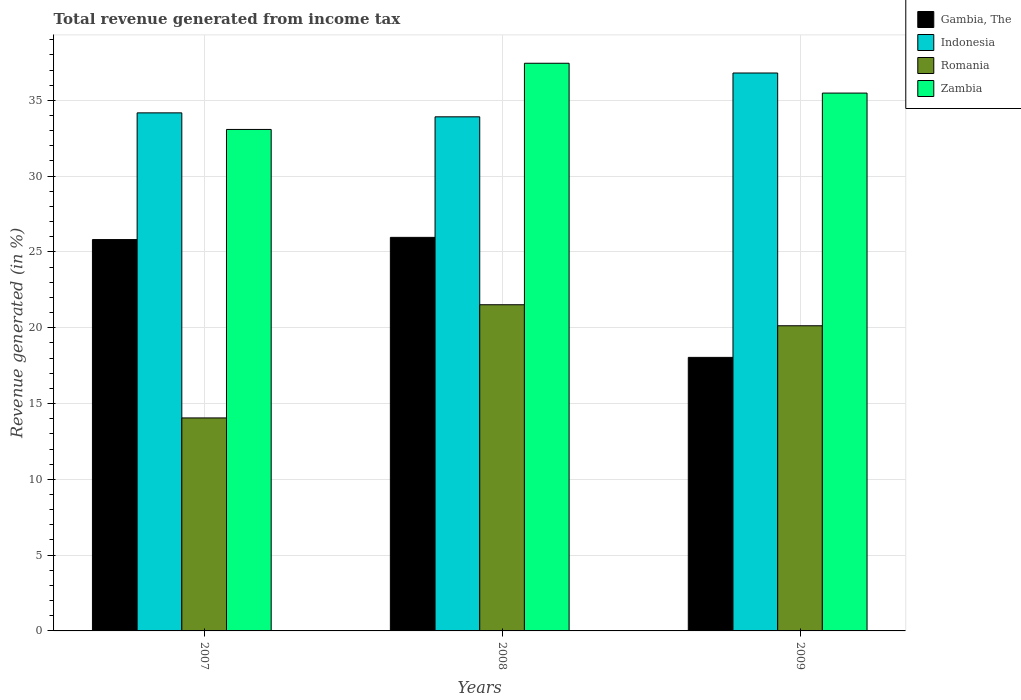How many different coloured bars are there?
Give a very brief answer. 4. Are the number of bars per tick equal to the number of legend labels?
Offer a terse response. Yes. Are the number of bars on each tick of the X-axis equal?
Keep it short and to the point. Yes. How many bars are there on the 2nd tick from the right?
Keep it short and to the point. 4. In how many cases, is the number of bars for a given year not equal to the number of legend labels?
Ensure brevity in your answer.  0. What is the total revenue generated in Gambia, The in 2009?
Make the answer very short. 18.04. Across all years, what is the maximum total revenue generated in Indonesia?
Your response must be concise. 36.8. Across all years, what is the minimum total revenue generated in Zambia?
Ensure brevity in your answer.  33.08. What is the total total revenue generated in Indonesia in the graph?
Make the answer very short. 104.89. What is the difference between the total revenue generated in Zambia in 2007 and that in 2009?
Your answer should be very brief. -2.4. What is the difference between the total revenue generated in Zambia in 2007 and the total revenue generated in Gambia, The in 2009?
Provide a succinct answer. 15.04. What is the average total revenue generated in Romania per year?
Keep it short and to the point. 18.57. In the year 2007, what is the difference between the total revenue generated in Zambia and total revenue generated in Gambia, The?
Provide a short and direct response. 7.26. What is the ratio of the total revenue generated in Indonesia in 2007 to that in 2009?
Make the answer very short. 0.93. What is the difference between the highest and the second highest total revenue generated in Romania?
Make the answer very short. 1.39. What is the difference between the highest and the lowest total revenue generated in Indonesia?
Keep it short and to the point. 2.89. In how many years, is the total revenue generated in Romania greater than the average total revenue generated in Romania taken over all years?
Your answer should be very brief. 2. Is the sum of the total revenue generated in Romania in 2008 and 2009 greater than the maximum total revenue generated in Zambia across all years?
Your answer should be compact. Yes. What does the 3rd bar from the left in 2009 represents?
Keep it short and to the point. Romania. What does the 4th bar from the right in 2008 represents?
Offer a very short reply. Gambia, The. How many bars are there?
Offer a terse response. 12. Are all the bars in the graph horizontal?
Ensure brevity in your answer.  No. What is the difference between two consecutive major ticks on the Y-axis?
Offer a very short reply. 5. Where does the legend appear in the graph?
Offer a very short reply. Top right. How are the legend labels stacked?
Provide a short and direct response. Vertical. What is the title of the graph?
Provide a short and direct response. Total revenue generated from income tax. What is the label or title of the Y-axis?
Give a very brief answer. Revenue generated (in %). What is the Revenue generated (in %) of Gambia, The in 2007?
Ensure brevity in your answer.  25.82. What is the Revenue generated (in %) of Indonesia in 2007?
Offer a very short reply. 34.17. What is the Revenue generated (in %) in Romania in 2007?
Your response must be concise. 14.05. What is the Revenue generated (in %) of Zambia in 2007?
Offer a terse response. 33.08. What is the Revenue generated (in %) in Gambia, The in 2008?
Offer a terse response. 25.96. What is the Revenue generated (in %) of Indonesia in 2008?
Provide a short and direct response. 33.91. What is the Revenue generated (in %) in Romania in 2008?
Give a very brief answer. 21.52. What is the Revenue generated (in %) of Zambia in 2008?
Your response must be concise. 37.45. What is the Revenue generated (in %) in Gambia, The in 2009?
Make the answer very short. 18.04. What is the Revenue generated (in %) in Indonesia in 2009?
Provide a short and direct response. 36.8. What is the Revenue generated (in %) of Romania in 2009?
Make the answer very short. 20.13. What is the Revenue generated (in %) of Zambia in 2009?
Offer a terse response. 35.48. Across all years, what is the maximum Revenue generated (in %) of Gambia, The?
Your answer should be compact. 25.96. Across all years, what is the maximum Revenue generated (in %) in Indonesia?
Ensure brevity in your answer.  36.8. Across all years, what is the maximum Revenue generated (in %) in Romania?
Your response must be concise. 21.52. Across all years, what is the maximum Revenue generated (in %) of Zambia?
Keep it short and to the point. 37.45. Across all years, what is the minimum Revenue generated (in %) of Gambia, The?
Make the answer very short. 18.04. Across all years, what is the minimum Revenue generated (in %) of Indonesia?
Keep it short and to the point. 33.91. Across all years, what is the minimum Revenue generated (in %) in Romania?
Your response must be concise. 14.05. Across all years, what is the minimum Revenue generated (in %) in Zambia?
Your answer should be compact. 33.08. What is the total Revenue generated (in %) of Gambia, The in the graph?
Your answer should be very brief. 69.82. What is the total Revenue generated (in %) in Indonesia in the graph?
Give a very brief answer. 104.89. What is the total Revenue generated (in %) in Romania in the graph?
Your response must be concise. 55.7. What is the total Revenue generated (in %) of Zambia in the graph?
Give a very brief answer. 106.01. What is the difference between the Revenue generated (in %) in Gambia, The in 2007 and that in 2008?
Make the answer very short. -0.15. What is the difference between the Revenue generated (in %) of Indonesia in 2007 and that in 2008?
Your answer should be very brief. 0.26. What is the difference between the Revenue generated (in %) of Romania in 2007 and that in 2008?
Provide a short and direct response. -7.47. What is the difference between the Revenue generated (in %) of Zambia in 2007 and that in 2008?
Give a very brief answer. -4.37. What is the difference between the Revenue generated (in %) of Gambia, The in 2007 and that in 2009?
Your answer should be compact. 7.77. What is the difference between the Revenue generated (in %) of Indonesia in 2007 and that in 2009?
Provide a succinct answer. -2.63. What is the difference between the Revenue generated (in %) in Romania in 2007 and that in 2009?
Give a very brief answer. -6.08. What is the difference between the Revenue generated (in %) in Zambia in 2007 and that in 2009?
Make the answer very short. -2.4. What is the difference between the Revenue generated (in %) in Gambia, The in 2008 and that in 2009?
Offer a very short reply. 7.92. What is the difference between the Revenue generated (in %) of Indonesia in 2008 and that in 2009?
Provide a succinct answer. -2.89. What is the difference between the Revenue generated (in %) of Romania in 2008 and that in 2009?
Offer a very short reply. 1.39. What is the difference between the Revenue generated (in %) of Zambia in 2008 and that in 2009?
Provide a short and direct response. 1.97. What is the difference between the Revenue generated (in %) of Gambia, The in 2007 and the Revenue generated (in %) of Indonesia in 2008?
Provide a succinct answer. -8.1. What is the difference between the Revenue generated (in %) of Gambia, The in 2007 and the Revenue generated (in %) of Romania in 2008?
Ensure brevity in your answer.  4.3. What is the difference between the Revenue generated (in %) in Gambia, The in 2007 and the Revenue generated (in %) in Zambia in 2008?
Give a very brief answer. -11.63. What is the difference between the Revenue generated (in %) in Indonesia in 2007 and the Revenue generated (in %) in Romania in 2008?
Your response must be concise. 12.66. What is the difference between the Revenue generated (in %) in Indonesia in 2007 and the Revenue generated (in %) in Zambia in 2008?
Your answer should be very brief. -3.27. What is the difference between the Revenue generated (in %) of Romania in 2007 and the Revenue generated (in %) of Zambia in 2008?
Your answer should be compact. -23.4. What is the difference between the Revenue generated (in %) of Gambia, The in 2007 and the Revenue generated (in %) of Indonesia in 2009?
Provide a short and direct response. -10.99. What is the difference between the Revenue generated (in %) in Gambia, The in 2007 and the Revenue generated (in %) in Romania in 2009?
Your response must be concise. 5.69. What is the difference between the Revenue generated (in %) in Gambia, The in 2007 and the Revenue generated (in %) in Zambia in 2009?
Ensure brevity in your answer.  -9.66. What is the difference between the Revenue generated (in %) of Indonesia in 2007 and the Revenue generated (in %) of Romania in 2009?
Ensure brevity in your answer.  14.04. What is the difference between the Revenue generated (in %) of Indonesia in 2007 and the Revenue generated (in %) of Zambia in 2009?
Offer a terse response. -1.3. What is the difference between the Revenue generated (in %) of Romania in 2007 and the Revenue generated (in %) of Zambia in 2009?
Your answer should be very brief. -21.43. What is the difference between the Revenue generated (in %) in Gambia, The in 2008 and the Revenue generated (in %) in Indonesia in 2009?
Make the answer very short. -10.84. What is the difference between the Revenue generated (in %) of Gambia, The in 2008 and the Revenue generated (in %) of Romania in 2009?
Offer a very short reply. 5.83. What is the difference between the Revenue generated (in %) of Gambia, The in 2008 and the Revenue generated (in %) of Zambia in 2009?
Your response must be concise. -9.52. What is the difference between the Revenue generated (in %) in Indonesia in 2008 and the Revenue generated (in %) in Romania in 2009?
Offer a very short reply. 13.78. What is the difference between the Revenue generated (in %) in Indonesia in 2008 and the Revenue generated (in %) in Zambia in 2009?
Keep it short and to the point. -1.57. What is the difference between the Revenue generated (in %) of Romania in 2008 and the Revenue generated (in %) of Zambia in 2009?
Provide a succinct answer. -13.96. What is the average Revenue generated (in %) in Gambia, The per year?
Your answer should be very brief. 23.27. What is the average Revenue generated (in %) of Indonesia per year?
Your response must be concise. 34.96. What is the average Revenue generated (in %) of Romania per year?
Your answer should be compact. 18.57. What is the average Revenue generated (in %) in Zambia per year?
Make the answer very short. 35.34. In the year 2007, what is the difference between the Revenue generated (in %) in Gambia, The and Revenue generated (in %) in Indonesia?
Make the answer very short. -8.36. In the year 2007, what is the difference between the Revenue generated (in %) of Gambia, The and Revenue generated (in %) of Romania?
Your answer should be very brief. 11.77. In the year 2007, what is the difference between the Revenue generated (in %) in Gambia, The and Revenue generated (in %) in Zambia?
Your answer should be very brief. -7.26. In the year 2007, what is the difference between the Revenue generated (in %) of Indonesia and Revenue generated (in %) of Romania?
Your answer should be compact. 20.12. In the year 2007, what is the difference between the Revenue generated (in %) in Indonesia and Revenue generated (in %) in Zambia?
Provide a succinct answer. 1.09. In the year 2007, what is the difference between the Revenue generated (in %) of Romania and Revenue generated (in %) of Zambia?
Give a very brief answer. -19.03. In the year 2008, what is the difference between the Revenue generated (in %) in Gambia, The and Revenue generated (in %) in Indonesia?
Ensure brevity in your answer.  -7.95. In the year 2008, what is the difference between the Revenue generated (in %) of Gambia, The and Revenue generated (in %) of Romania?
Your answer should be compact. 4.44. In the year 2008, what is the difference between the Revenue generated (in %) of Gambia, The and Revenue generated (in %) of Zambia?
Ensure brevity in your answer.  -11.48. In the year 2008, what is the difference between the Revenue generated (in %) in Indonesia and Revenue generated (in %) in Romania?
Your response must be concise. 12.4. In the year 2008, what is the difference between the Revenue generated (in %) of Indonesia and Revenue generated (in %) of Zambia?
Your answer should be very brief. -3.53. In the year 2008, what is the difference between the Revenue generated (in %) in Romania and Revenue generated (in %) in Zambia?
Give a very brief answer. -15.93. In the year 2009, what is the difference between the Revenue generated (in %) in Gambia, The and Revenue generated (in %) in Indonesia?
Keep it short and to the point. -18.76. In the year 2009, what is the difference between the Revenue generated (in %) of Gambia, The and Revenue generated (in %) of Romania?
Ensure brevity in your answer.  -2.09. In the year 2009, what is the difference between the Revenue generated (in %) of Gambia, The and Revenue generated (in %) of Zambia?
Make the answer very short. -17.43. In the year 2009, what is the difference between the Revenue generated (in %) of Indonesia and Revenue generated (in %) of Romania?
Your answer should be very brief. 16.67. In the year 2009, what is the difference between the Revenue generated (in %) in Indonesia and Revenue generated (in %) in Zambia?
Provide a succinct answer. 1.32. In the year 2009, what is the difference between the Revenue generated (in %) of Romania and Revenue generated (in %) of Zambia?
Ensure brevity in your answer.  -15.35. What is the ratio of the Revenue generated (in %) in Gambia, The in 2007 to that in 2008?
Your answer should be very brief. 0.99. What is the ratio of the Revenue generated (in %) in Indonesia in 2007 to that in 2008?
Your answer should be very brief. 1.01. What is the ratio of the Revenue generated (in %) of Romania in 2007 to that in 2008?
Ensure brevity in your answer.  0.65. What is the ratio of the Revenue generated (in %) of Zambia in 2007 to that in 2008?
Your response must be concise. 0.88. What is the ratio of the Revenue generated (in %) in Gambia, The in 2007 to that in 2009?
Make the answer very short. 1.43. What is the ratio of the Revenue generated (in %) of Romania in 2007 to that in 2009?
Make the answer very short. 0.7. What is the ratio of the Revenue generated (in %) of Zambia in 2007 to that in 2009?
Your answer should be very brief. 0.93. What is the ratio of the Revenue generated (in %) in Gambia, The in 2008 to that in 2009?
Ensure brevity in your answer.  1.44. What is the ratio of the Revenue generated (in %) in Indonesia in 2008 to that in 2009?
Your answer should be very brief. 0.92. What is the ratio of the Revenue generated (in %) of Romania in 2008 to that in 2009?
Provide a short and direct response. 1.07. What is the ratio of the Revenue generated (in %) in Zambia in 2008 to that in 2009?
Your response must be concise. 1.06. What is the difference between the highest and the second highest Revenue generated (in %) in Gambia, The?
Provide a succinct answer. 0.15. What is the difference between the highest and the second highest Revenue generated (in %) in Indonesia?
Keep it short and to the point. 2.63. What is the difference between the highest and the second highest Revenue generated (in %) of Romania?
Keep it short and to the point. 1.39. What is the difference between the highest and the second highest Revenue generated (in %) in Zambia?
Keep it short and to the point. 1.97. What is the difference between the highest and the lowest Revenue generated (in %) in Gambia, The?
Your response must be concise. 7.92. What is the difference between the highest and the lowest Revenue generated (in %) in Indonesia?
Provide a short and direct response. 2.89. What is the difference between the highest and the lowest Revenue generated (in %) of Romania?
Your answer should be very brief. 7.47. What is the difference between the highest and the lowest Revenue generated (in %) in Zambia?
Make the answer very short. 4.37. 